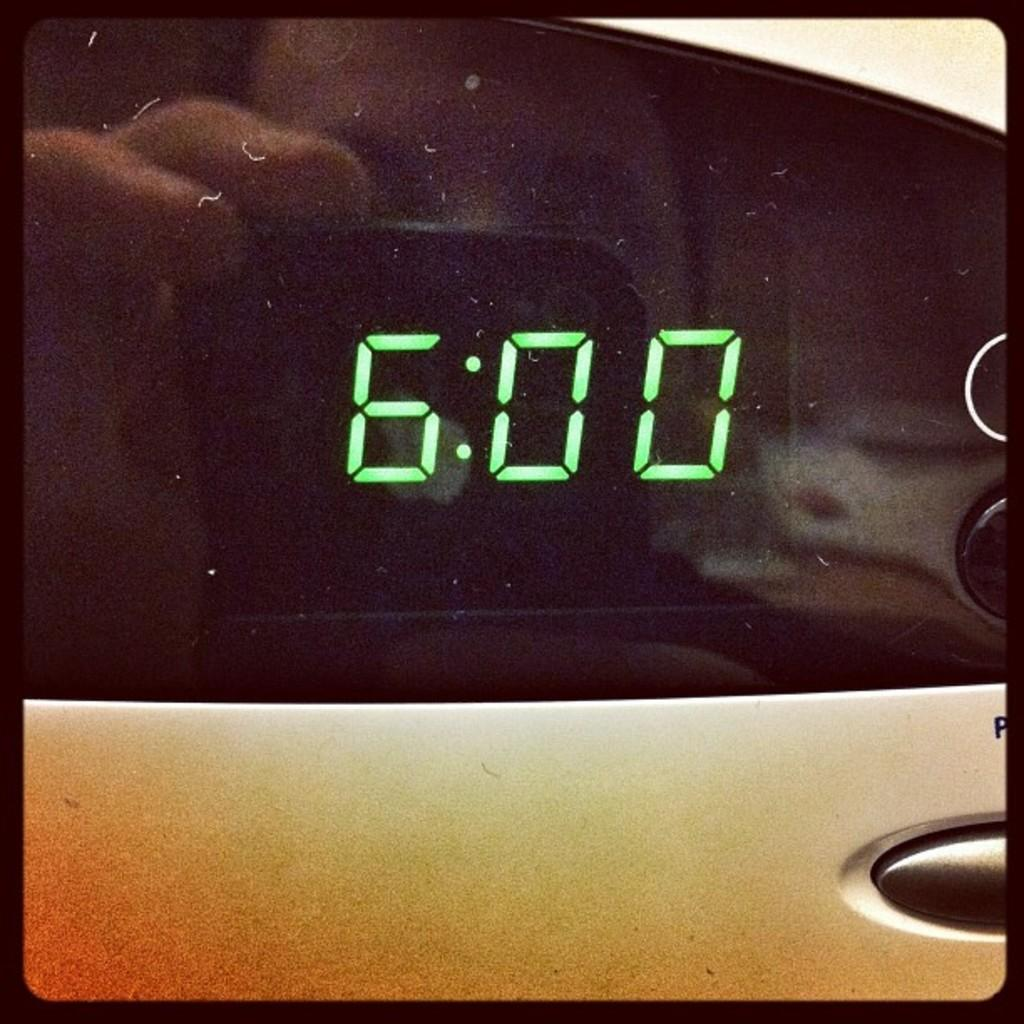Provide a one-sentence caption for the provided image. A digital clock display with 6:00 glowing in green. 